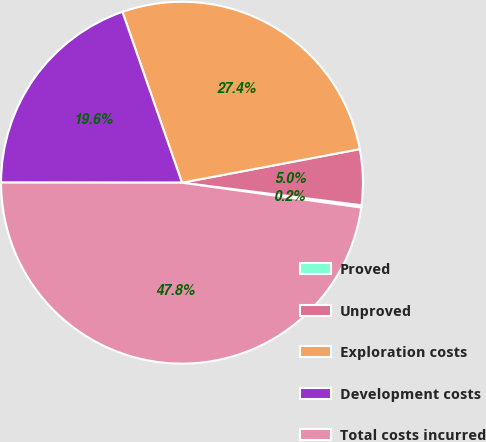Convert chart. <chart><loc_0><loc_0><loc_500><loc_500><pie_chart><fcel>Proved<fcel>Unproved<fcel>Exploration costs<fcel>Development costs<fcel>Total costs incurred<nl><fcel>0.2%<fcel>4.96%<fcel>27.37%<fcel>19.65%<fcel>47.82%<nl></chart> 